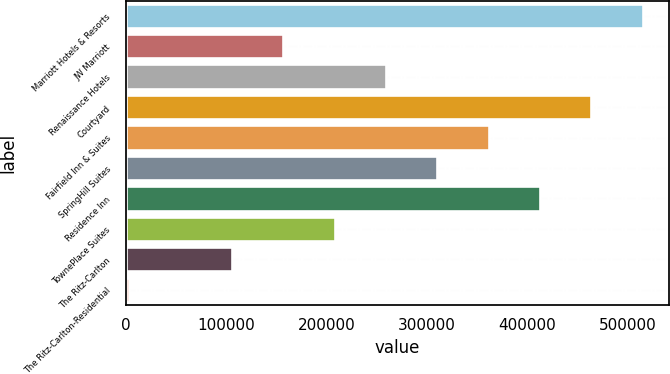Convert chart to OTSL. <chart><loc_0><loc_0><loc_500><loc_500><bar_chart><fcel>Marriott Hotels & Resorts<fcel>JW Marriott<fcel>Renaissance Hotels<fcel>Courtyard<fcel>Fairfield Inn & Suites<fcel>SpringHill Suites<fcel>Residence Inn<fcel>TownePlace Suites<fcel>The Ritz-Carlton<fcel>The Ritz-Carlton-Residential<nl><fcel>515356<fcel>157125<fcel>259477<fcel>464180<fcel>361829<fcel>310653<fcel>413004<fcel>208301<fcel>105950<fcel>3598<nl></chart> 